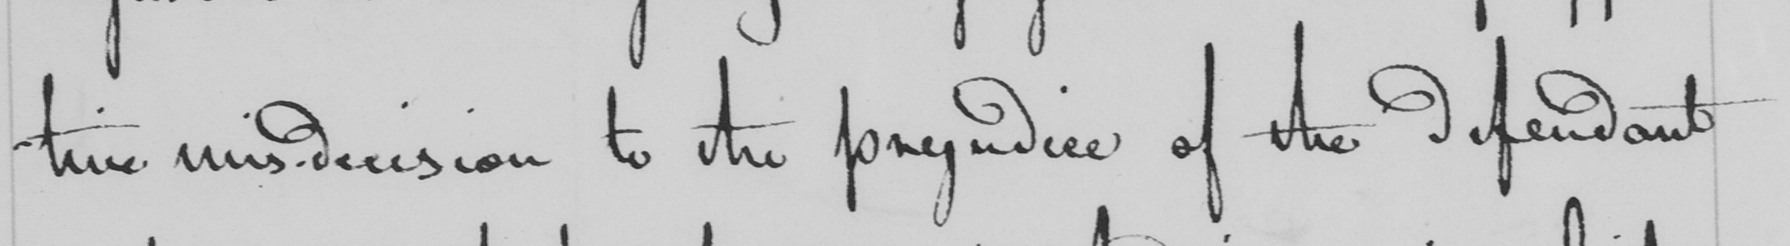Please provide the text content of this handwritten line. tive mis-decision to the prejudice of the defendant 